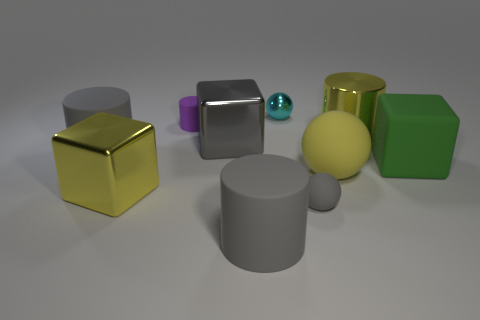What number of other objects are there of the same size as the green block?
Your answer should be very brief. 6. What number of objects are either rubber cylinders that are on the right side of the tiny purple matte cylinder or large gray matte things that are behind the matte cube?
Provide a succinct answer. 2. The yellow matte object that is the same size as the green block is what shape?
Your answer should be very brief. Sphere. What size is the yellow object that is the same material as the large yellow cylinder?
Keep it short and to the point. Large. Do the large gray shiny object and the large green object have the same shape?
Give a very brief answer. Yes. The sphere that is the same size as the gray metal cube is what color?
Offer a terse response. Yellow. What is the size of the yellow shiny thing that is the same shape as the purple thing?
Your answer should be compact. Large. The gray matte object behind the green matte object has what shape?
Ensure brevity in your answer.  Cylinder. There is a tiny gray rubber object; does it have the same shape as the gray matte object that is to the left of the tiny matte cylinder?
Give a very brief answer. No. Is the number of balls that are to the left of the tiny gray thing the same as the number of big yellow matte spheres that are behind the big ball?
Your answer should be very brief. No. 